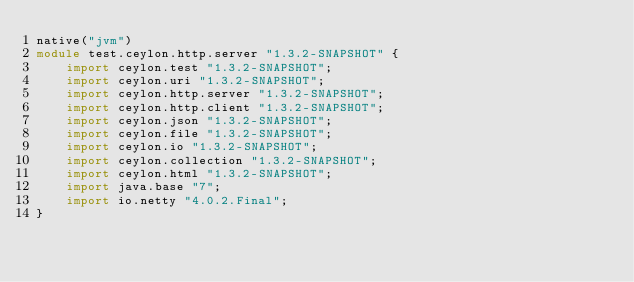Convert code to text. <code><loc_0><loc_0><loc_500><loc_500><_Ceylon_>native("jvm")
module test.ceylon.http.server "1.3.2-SNAPSHOT" {
    import ceylon.test "1.3.2-SNAPSHOT";
    import ceylon.uri "1.3.2-SNAPSHOT";
    import ceylon.http.server "1.3.2-SNAPSHOT";
    import ceylon.http.client "1.3.2-SNAPSHOT";
    import ceylon.json "1.3.2-SNAPSHOT";
    import ceylon.file "1.3.2-SNAPSHOT";
    import ceylon.io "1.3.2-SNAPSHOT";
    import ceylon.collection "1.3.2-SNAPSHOT";
    import ceylon.html "1.3.2-SNAPSHOT";
    import java.base "7";
    import io.netty "4.0.2.Final";
}
</code> 